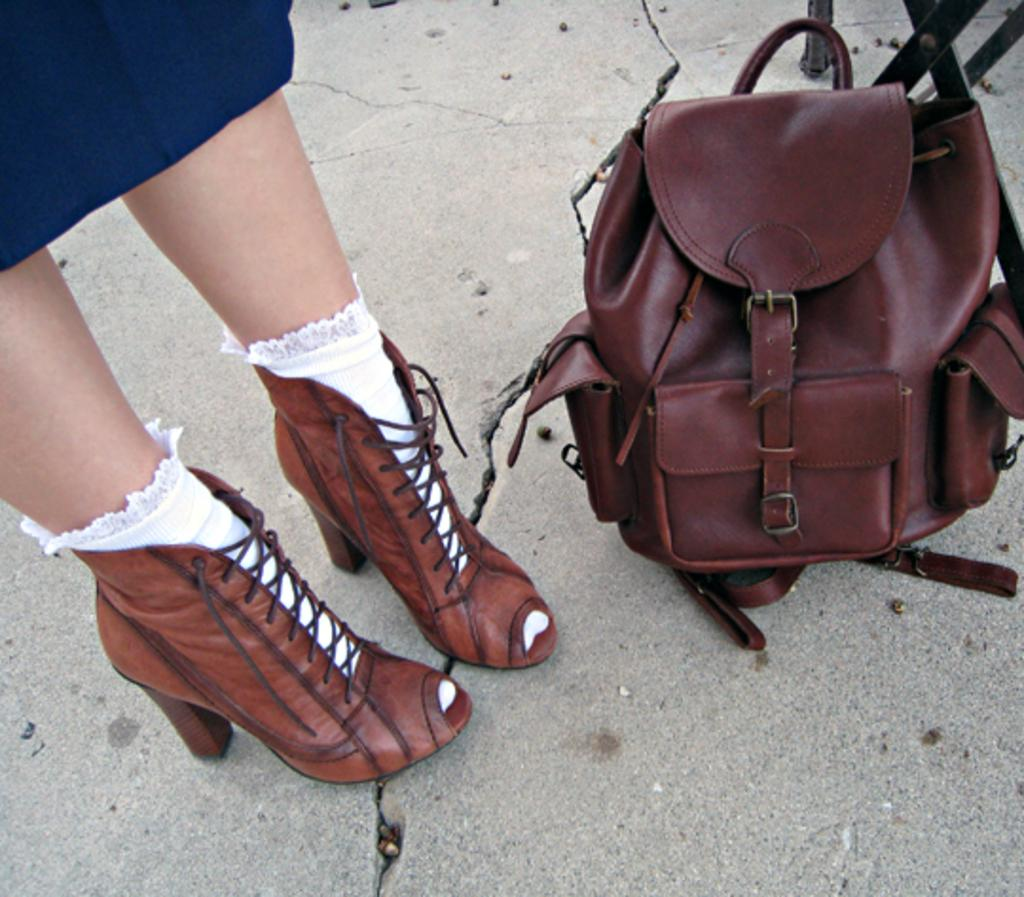What type of shoes is the woman wearing in the image? The woman is wearing brown shoes. What type of socks is the woman wearing in the image? The woman is wearing white socks. What is the woman's posture in the image? The woman is standing. What object is beside the woman in the image? There is a brown bag beside the woman. What type of yam is the woman holding in the image? There is no yam present in the image; the woman is not holding any yam. What title does the woman have in the image? There is no title associated with the woman in the image. 